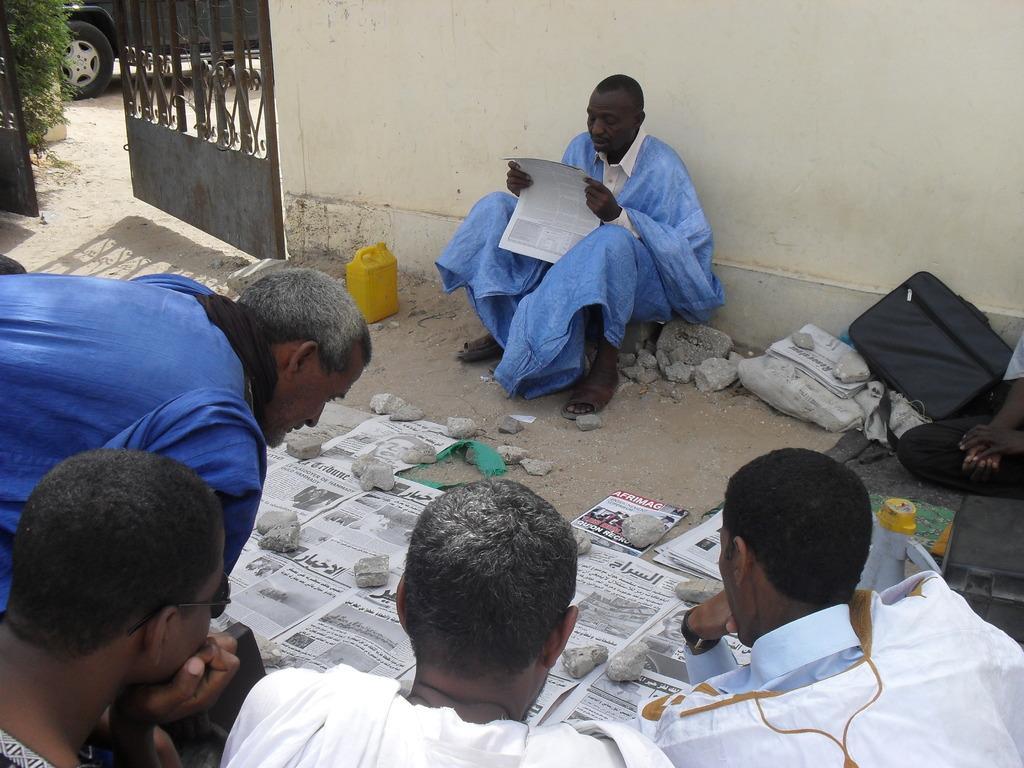In one or two sentences, can you explain what this image depicts? In this image I can see few people and one person is holding the paper. I can see few papers, stones, bags, gate, vehicle, plant and the yellow color object on the ground. 